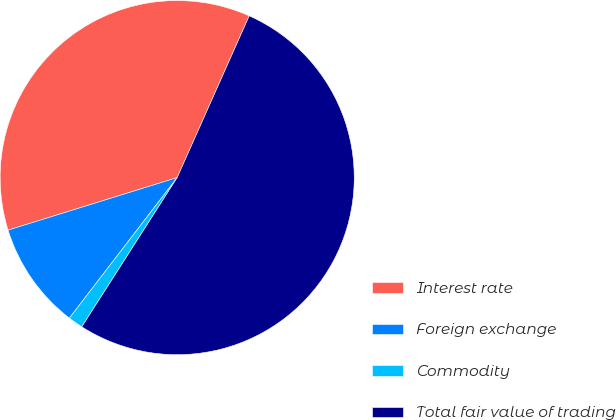<chart> <loc_0><loc_0><loc_500><loc_500><pie_chart><fcel>Interest rate<fcel>Foreign exchange<fcel>Commodity<fcel>Total fair value of trading<nl><fcel>36.46%<fcel>9.79%<fcel>1.36%<fcel>52.38%<nl></chart> 